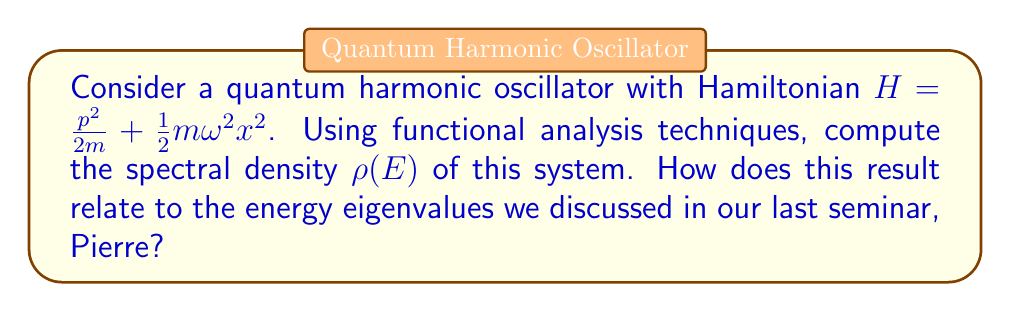Show me your answer to this math problem. Let's approach this step-by-step:

1) First, recall that the spectral density $\rho(E)$ is related to the trace of the resolvent operator $(H-E)^{-1}$:

   $$\rho(E) = -\frac{1}{\pi} \lim_{\epsilon \to 0^+} \text{Im}\, \text{Tr}(H-E-i\epsilon)^{-1}$$

2) For the quantum harmonic oscillator, we know the energy eigenvalues are:

   $$E_n = \hbar\omega(n+\frac{1}{2}), \quad n = 0, 1, 2, ...$$

3) The trace of the resolvent can be expressed as a sum over these eigenvalues:

   $$\text{Tr}(H-E-i\epsilon)^{-1} = \sum_{n=0}^{\infty} \frac{1}{E_n - E - i\epsilon}$$

4) Substituting the eigenvalues:

   $$\text{Tr}(H-E-i\epsilon)^{-1} = \sum_{n=0}^{\infty} \frac{1}{\hbar\omega(n+\frac{1}{2}) - E - i\epsilon}$$

5) This sum can be evaluated using complex analysis techniques. The result is:

   $$\text{Tr}(H-E-i\epsilon)^{-1} = \frac{1}{\hbar\omega} \frac{1}{e^{(E+i\epsilon)/\hbar\omega} - 1}$$

6) Now, taking the imaginary part and the limit:

   $$\rho(E) = -\frac{1}{\pi} \lim_{\epsilon \to 0^+} \text{Im}\, \frac{1}{\hbar\omega} \frac{1}{e^{(E+i\epsilon)/\hbar\omega} - 1}$$

7) Evaluating this limit:

   $$\rho(E) = \frac{1}{\hbar\omega} \sum_{n=0}^{\infty} \delta(E - E_n)$$

This result shows that the spectral density consists of a series of delta functions at the energy eigenvalues, spaced by $\hbar\omega$.
Answer: $$\rho(E) = \frac{1}{\hbar\omega} \sum_{n=0}^{\infty} \delta(E - \hbar\omega(n+\frac{1}{2}))$$ 